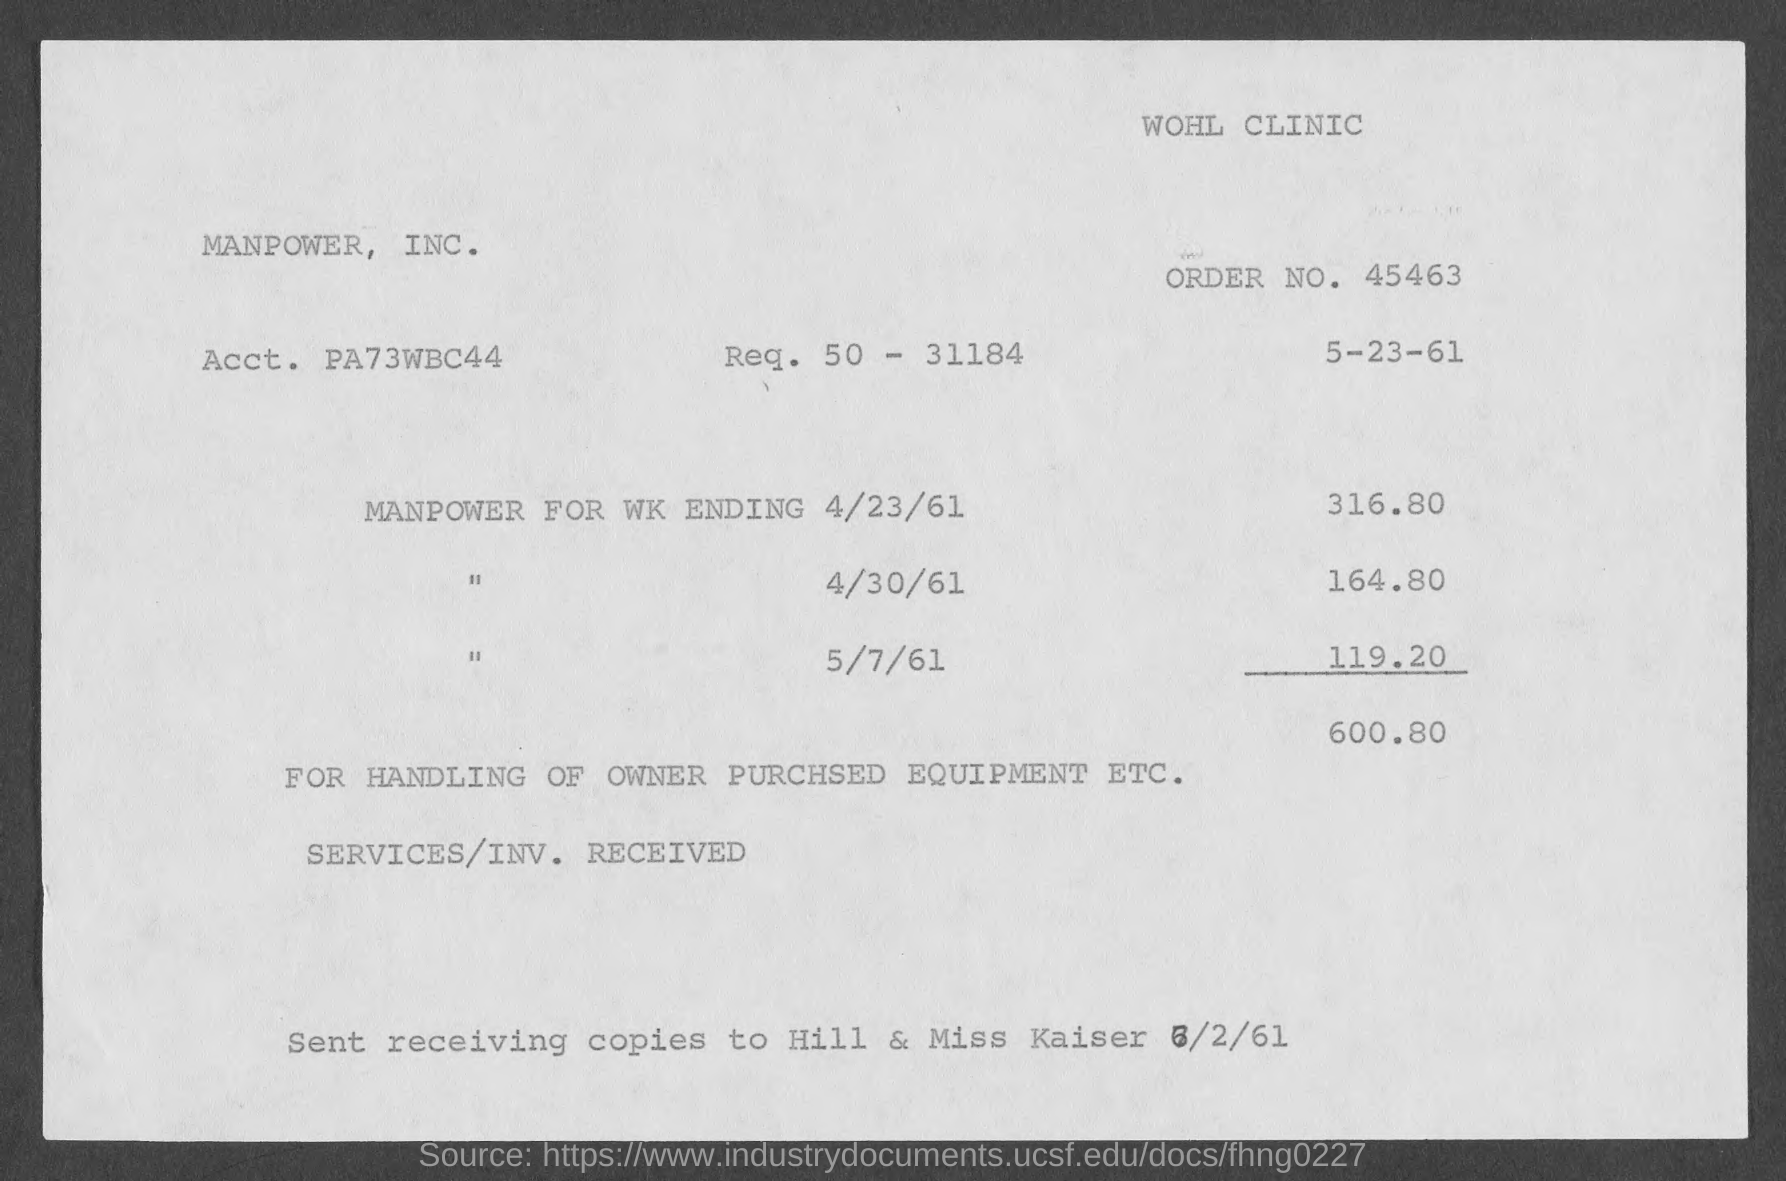Specify some key components in this picture. What is the account number? It is PA73WBC44.. I requested information about the order number, specifically asking for the order number 45463... 